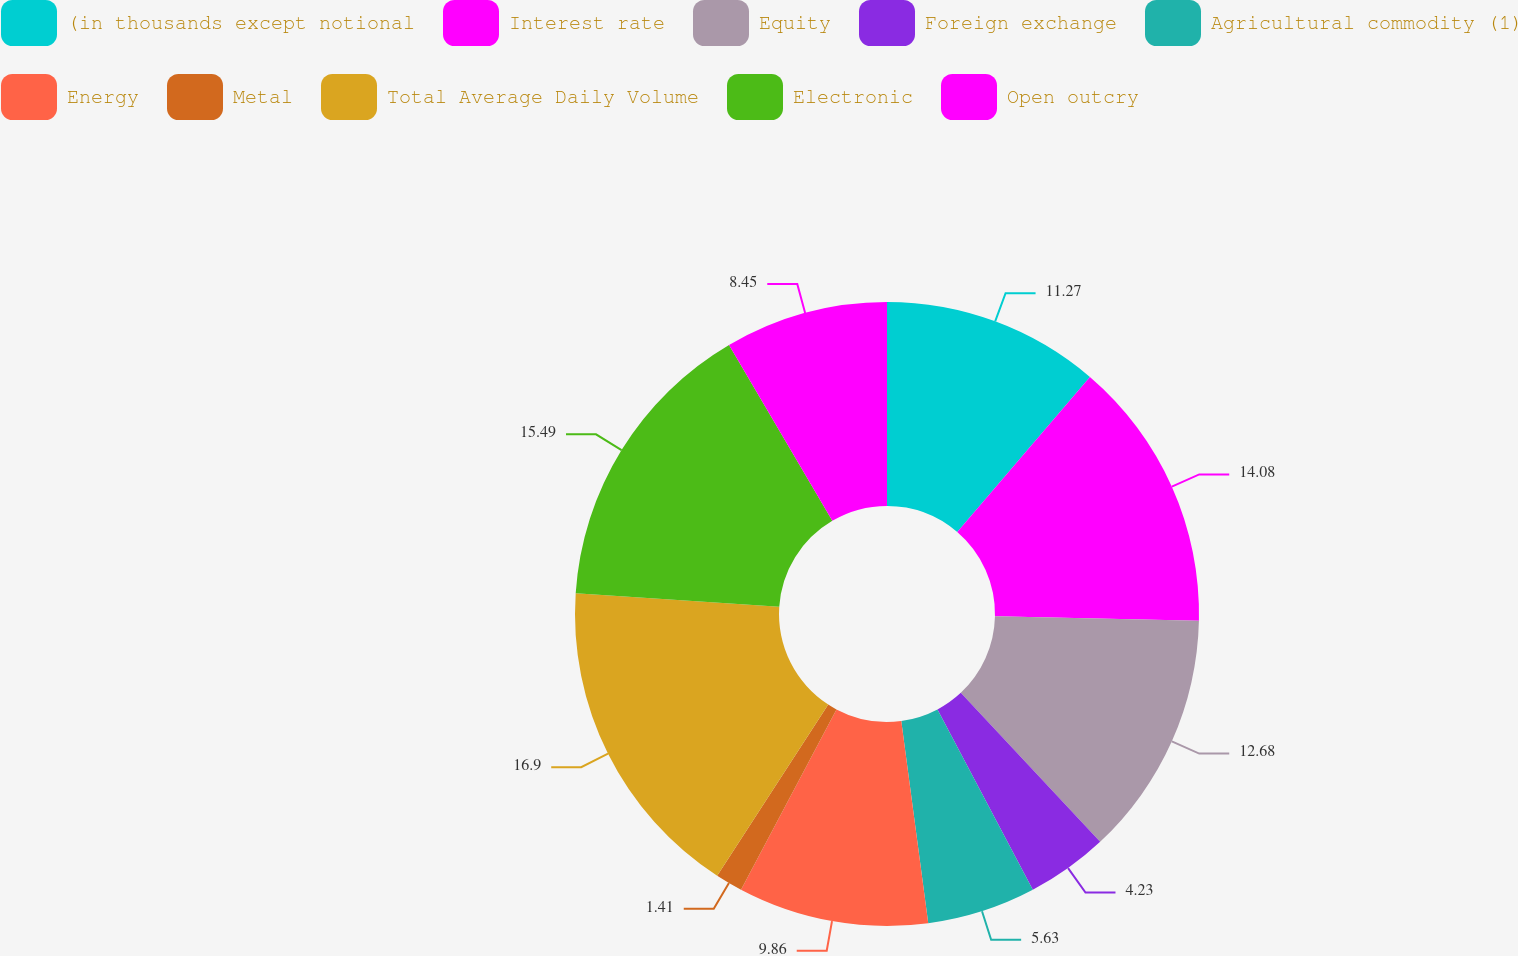<chart> <loc_0><loc_0><loc_500><loc_500><pie_chart><fcel>(in thousands except notional<fcel>Interest rate<fcel>Equity<fcel>Foreign exchange<fcel>Agricultural commodity (1)<fcel>Energy<fcel>Metal<fcel>Total Average Daily Volume<fcel>Electronic<fcel>Open outcry<nl><fcel>11.27%<fcel>14.08%<fcel>12.68%<fcel>4.23%<fcel>5.63%<fcel>9.86%<fcel>1.41%<fcel>16.9%<fcel>15.49%<fcel>8.45%<nl></chart> 